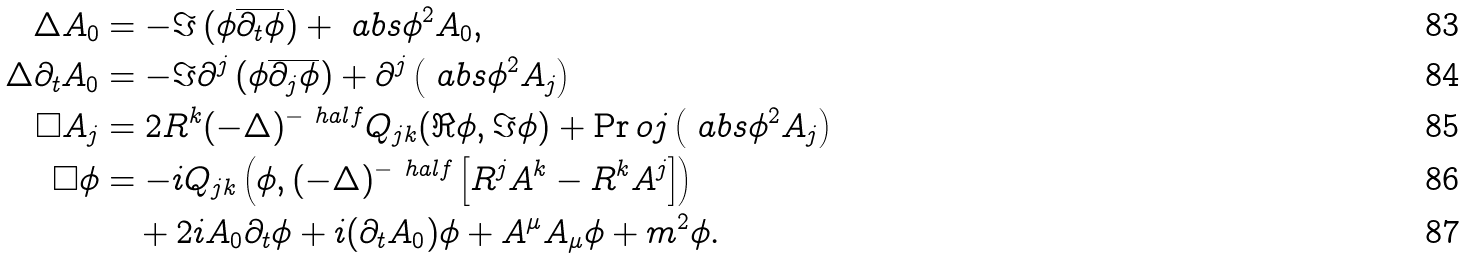Convert formula to latex. <formula><loc_0><loc_0><loc_500><loc_500>\Delta A _ { 0 } & = - \Im \left ( \phi \overline { \partial _ { t } \phi } \right ) + \ a b s { \phi } ^ { 2 } A _ { 0 } , \\ \Delta \partial _ { t } A _ { 0 } & = - \Im \partial ^ { j } \left ( \phi \overline { \partial _ { j } \phi } \right ) + \partial ^ { j } \left ( \ a b s { \phi } ^ { 2 } A _ { j } \right ) \\ \square A _ { j } & = 2 R ^ { k } ( - \Delta ) ^ { - \ h a l f } Q _ { j k } ( \Re \phi , \Im \phi ) + \Pr o j \left ( \ a b s { \phi } ^ { 2 } A _ { j } \right ) \\ \square \phi & = - i Q _ { j k } \left ( \phi , ( - \Delta ) ^ { - \ h a l f } \left [ R ^ { j } A ^ { k } - R ^ { k } A ^ { j } \right ] \right ) \\ & \quad + 2 i A _ { 0 } \partial _ { t } \phi + i ( \partial _ { t } A _ { 0 } ) \phi + A ^ { \mu } A _ { \mu } \phi + m ^ { 2 } \phi .</formula> 